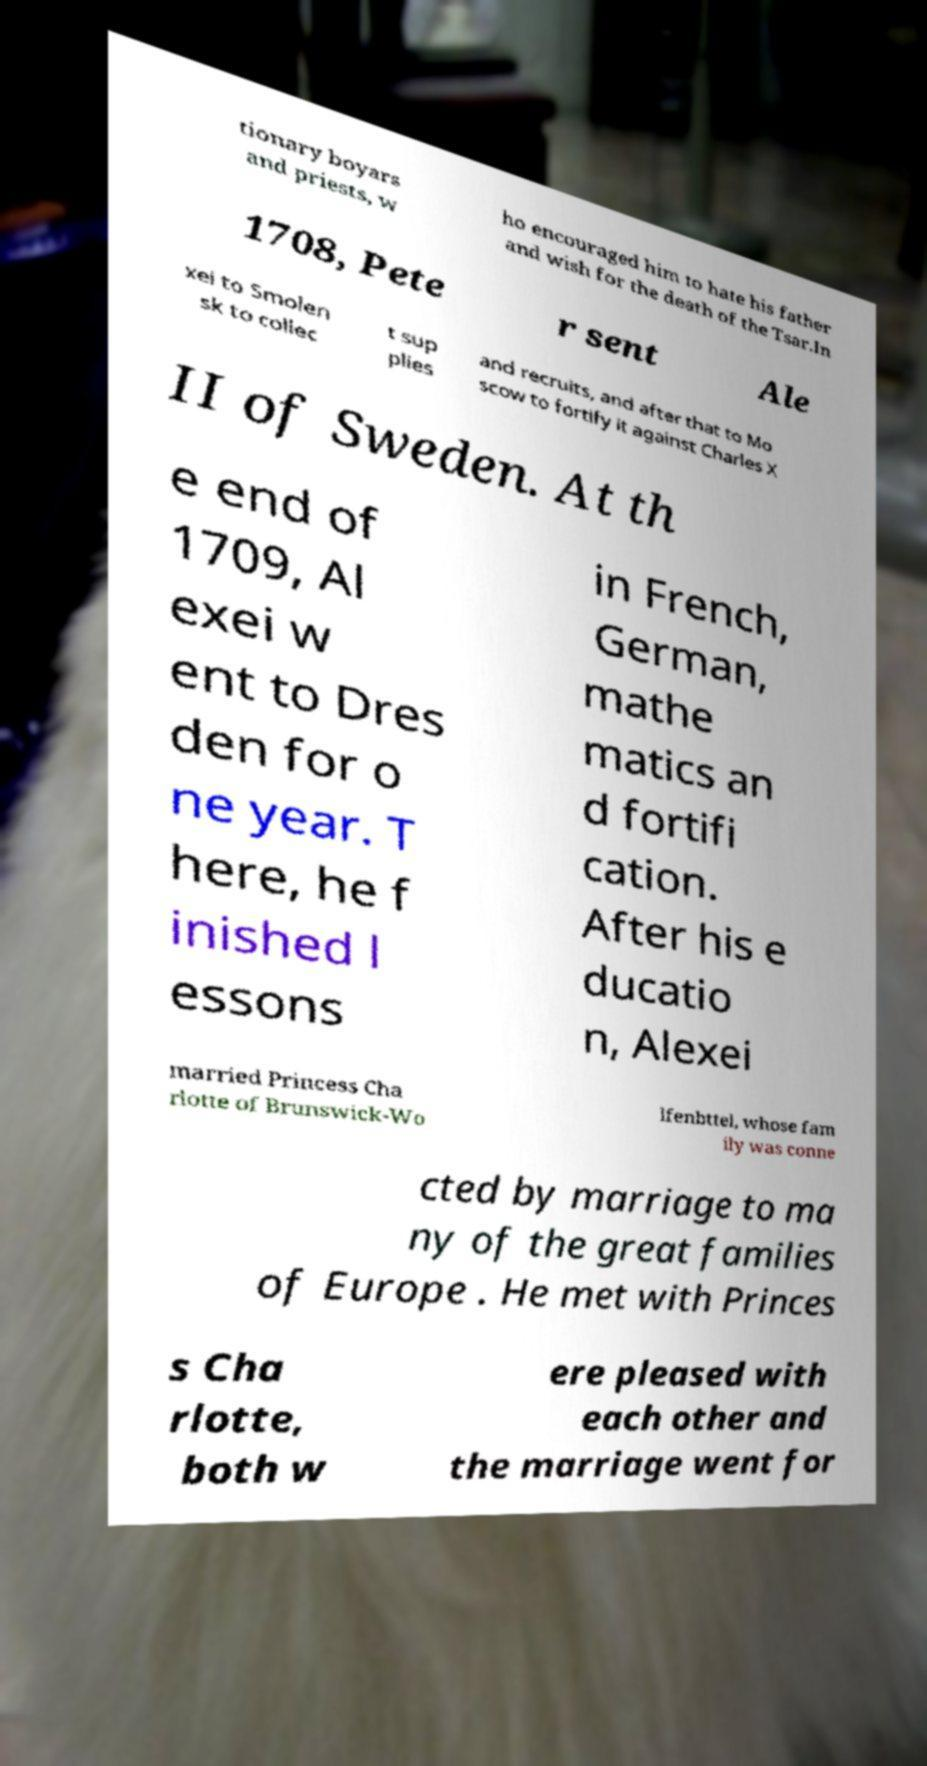Can you read and provide the text displayed in the image?This photo seems to have some interesting text. Can you extract and type it out for me? tionary boyars and priests, w ho encouraged him to hate his father and wish for the death of the Tsar.In 1708, Pete r sent Ale xei to Smolen sk to collec t sup plies and recruits, and after that to Mo scow to fortify it against Charles X II of Sweden. At th e end of 1709, Al exei w ent to Dres den for o ne year. T here, he f inished l essons in French, German, mathe matics an d fortifi cation. After his e ducatio n, Alexei married Princess Cha rlotte of Brunswick-Wo lfenbttel, whose fam ily was conne cted by marriage to ma ny of the great families of Europe . He met with Princes s Cha rlotte, both w ere pleased with each other and the marriage went for 